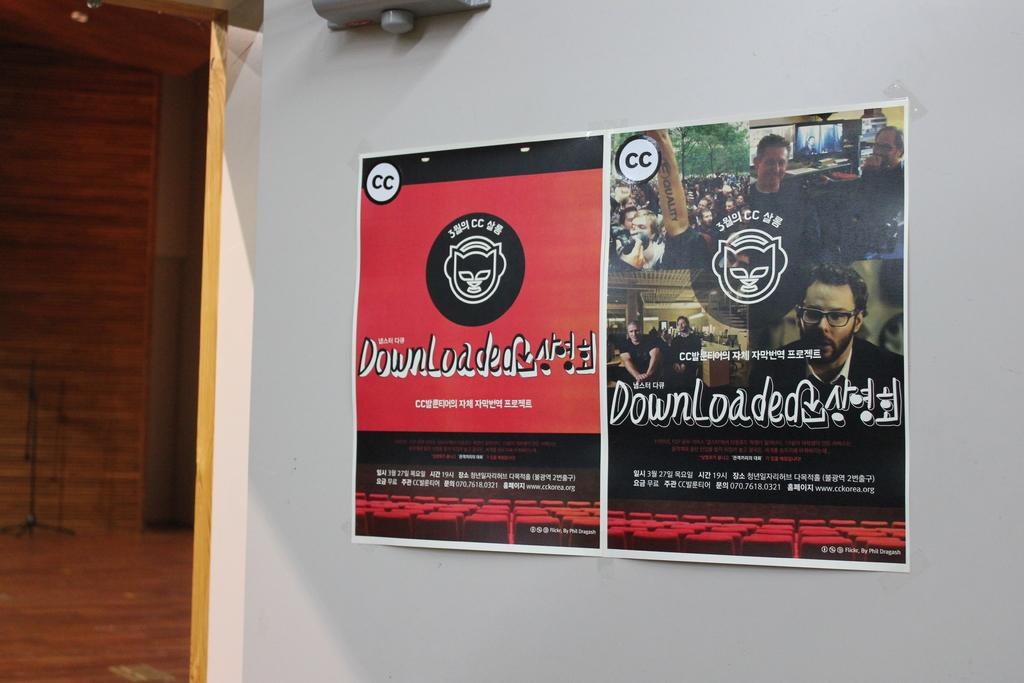Provide a one-sentence caption for the provided image. Two separate advertisement signs for Downloaded, one is red, the other has people in it. 